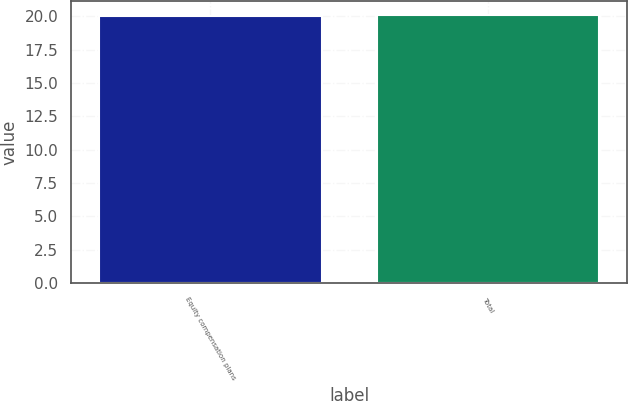<chart> <loc_0><loc_0><loc_500><loc_500><bar_chart><fcel>Equity compensation plans<fcel>Total<nl><fcel>20.01<fcel>20.11<nl></chart> 